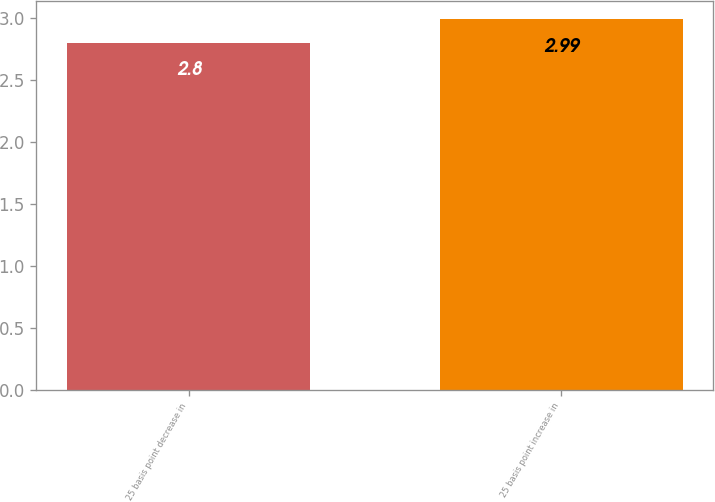<chart> <loc_0><loc_0><loc_500><loc_500><bar_chart><fcel>25 basis point decrease in<fcel>25 basis point increase in<nl><fcel>2.8<fcel>2.99<nl></chart> 